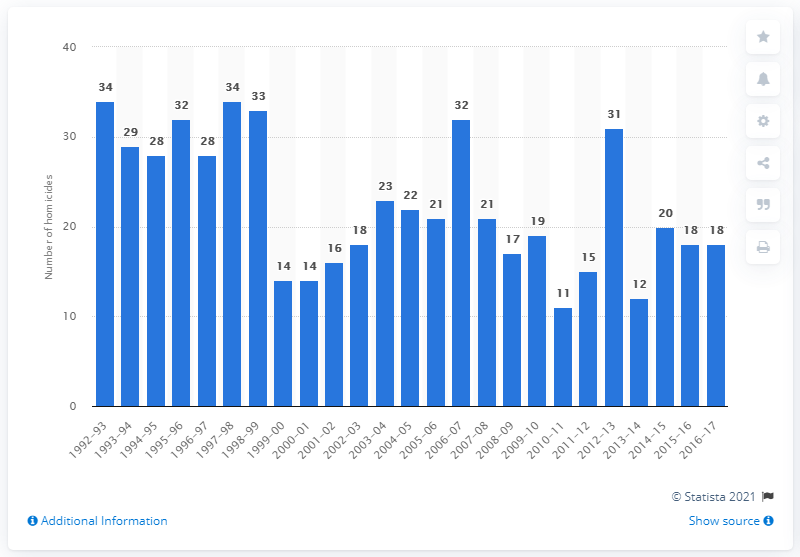Indicate a few pertinent items in this graphic. In the 2016-2017 academic year, 18 students were victims of homicide. 